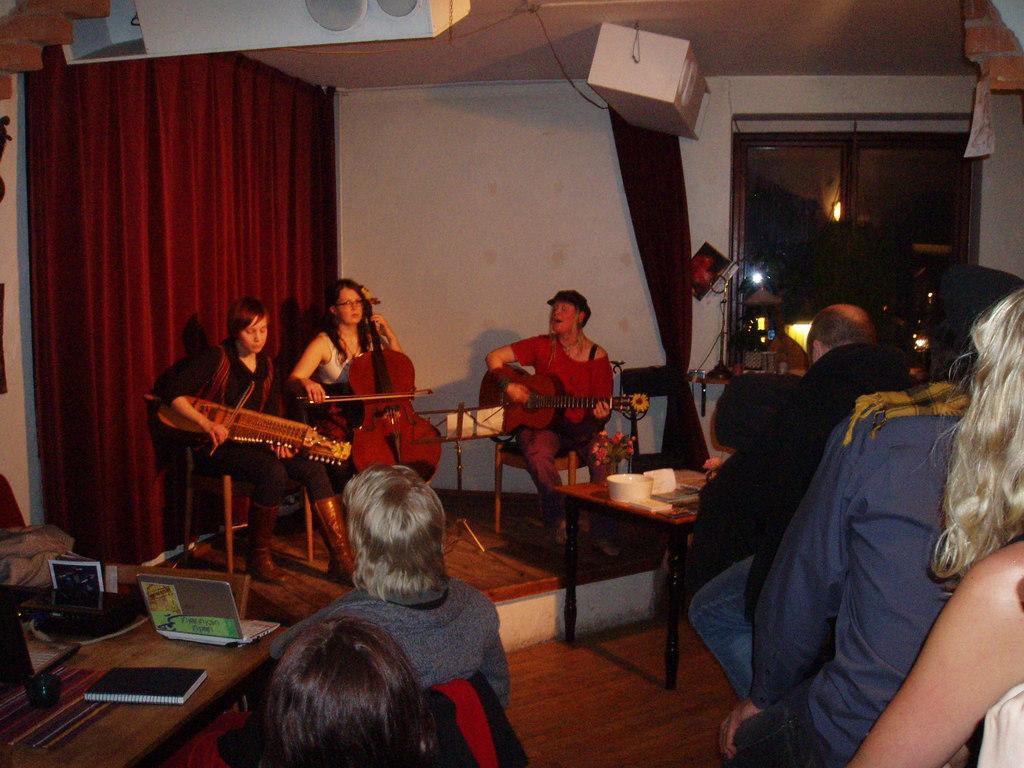Please provide a concise description of this image. In this image we can see a three women sitting on a chair and they are playing a guitar. Here we can see a few people who are sitting on a chair and they are watching these people. This is a wooden table where a laptop and a book are kept on it. 